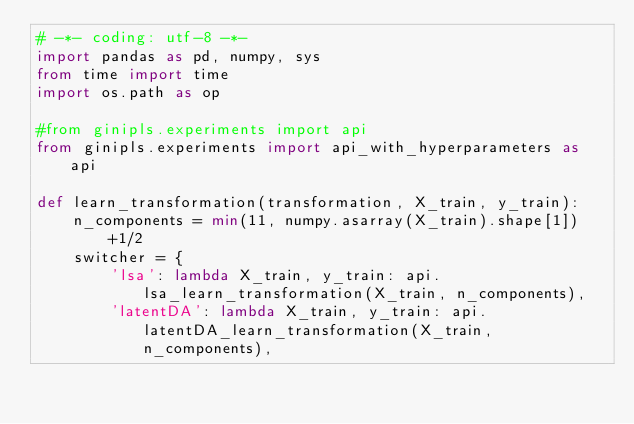<code> <loc_0><loc_0><loc_500><loc_500><_Python_># -*- coding: utf-8 -*-
import pandas as pd, numpy, sys
from time import time
import os.path as op

#from ginipls.experiments import api
from ginipls.experiments import api_with_hyperparameters as api

def learn_transformation(transformation, X_train, y_train):
    n_components = min(11, numpy.asarray(X_train).shape[1])+1/2
    switcher = {
        'lsa': lambda X_train, y_train: api.lsa_learn_transformation(X_train, n_components),
        'latentDA': lambda X_train, y_train: api.latentDA_learn_transformation(X_train, n_components),</code> 